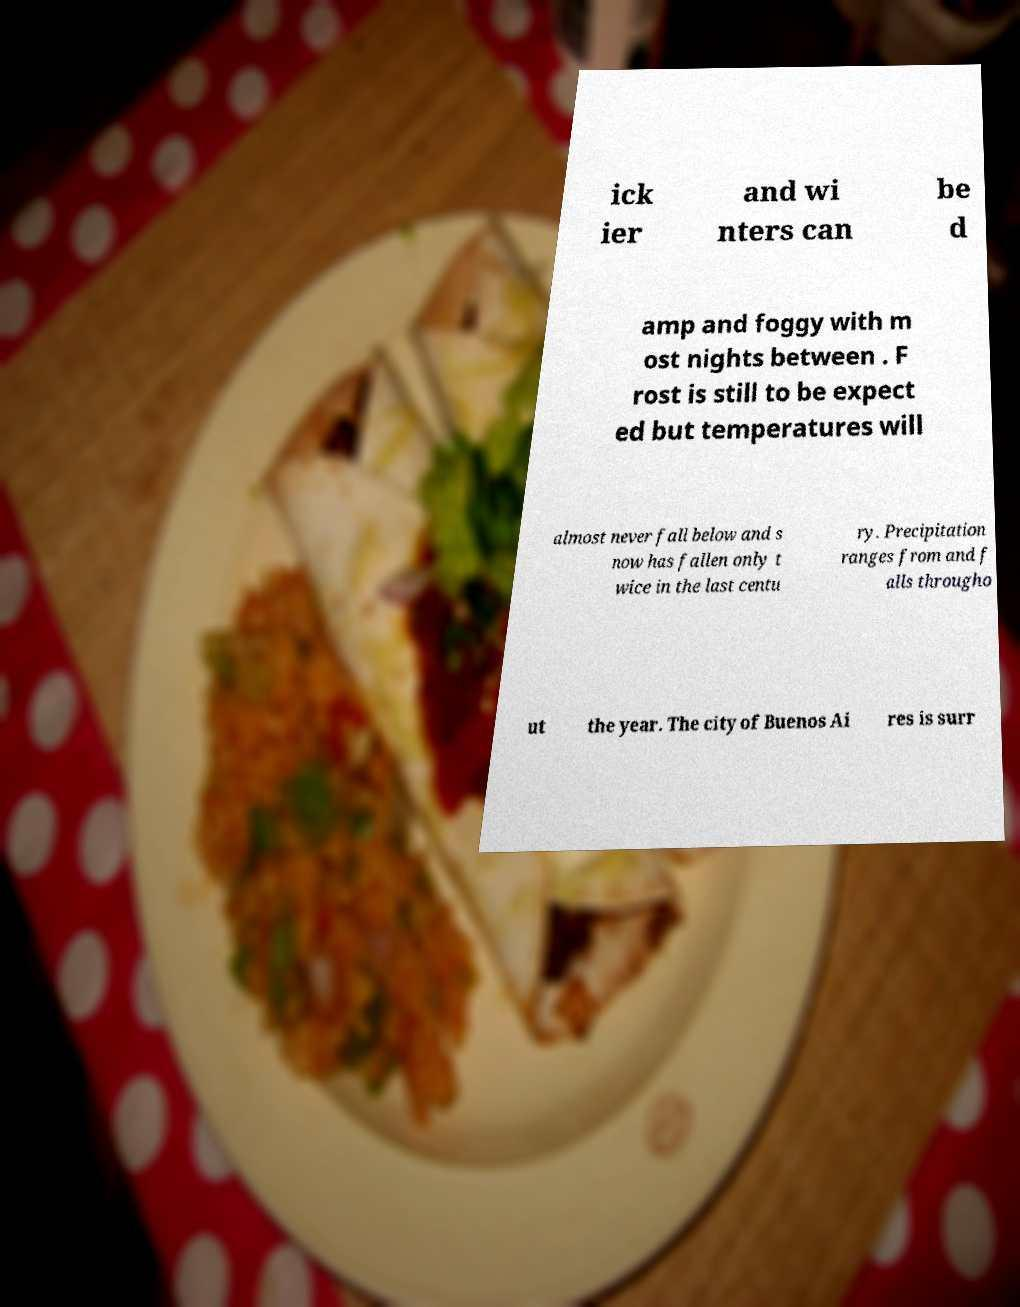Please read and relay the text visible in this image. What does it say? ick ier and wi nters can be d amp and foggy with m ost nights between . F rost is still to be expect ed but temperatures will almost never fall below and s now has fallen only t wice in the last centu ry. Precipitation ranges from and f alls througho ut the year. The city of Buenos Ai res is surr 